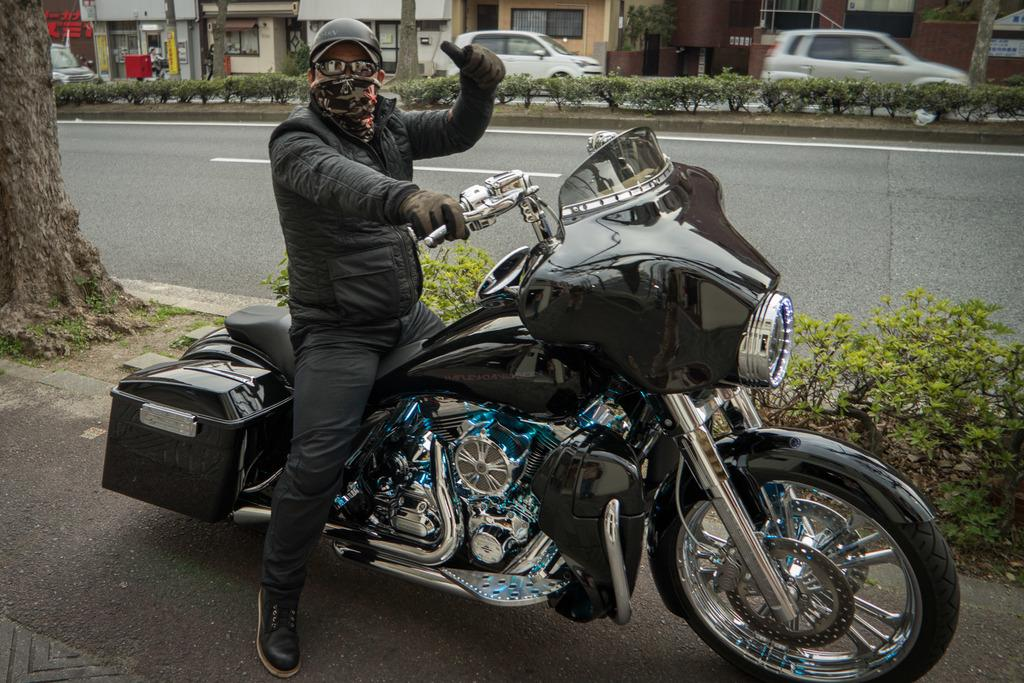What is the man in the image doing? The man is sitting on a bike in the image. What is the man wearing while sitting on the bike? The man is wearing a black jacket and a helmet. What can be seen in the background of the image? There is a tree trunk, a plant, a building, and cars visible in the background. What time does the clock on the bike show in the image? There is no clock present in the image, so it is not possible to determine the time. 